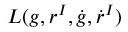Convert formula to latex. <formula><loc_0><loc_0><loc_500><loc_500>L ( g , r ^ { I } , \dot { g } , \dot { r } ^ { I } )</formula> 